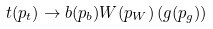<formula> <loc_0><loc_0><loc_500><loc_500>t ( p _ { t } ) \to b ( p _ { b } ) W ( p _ { W } ) \left ( g ( p _ { g } ) \right )</formula> 